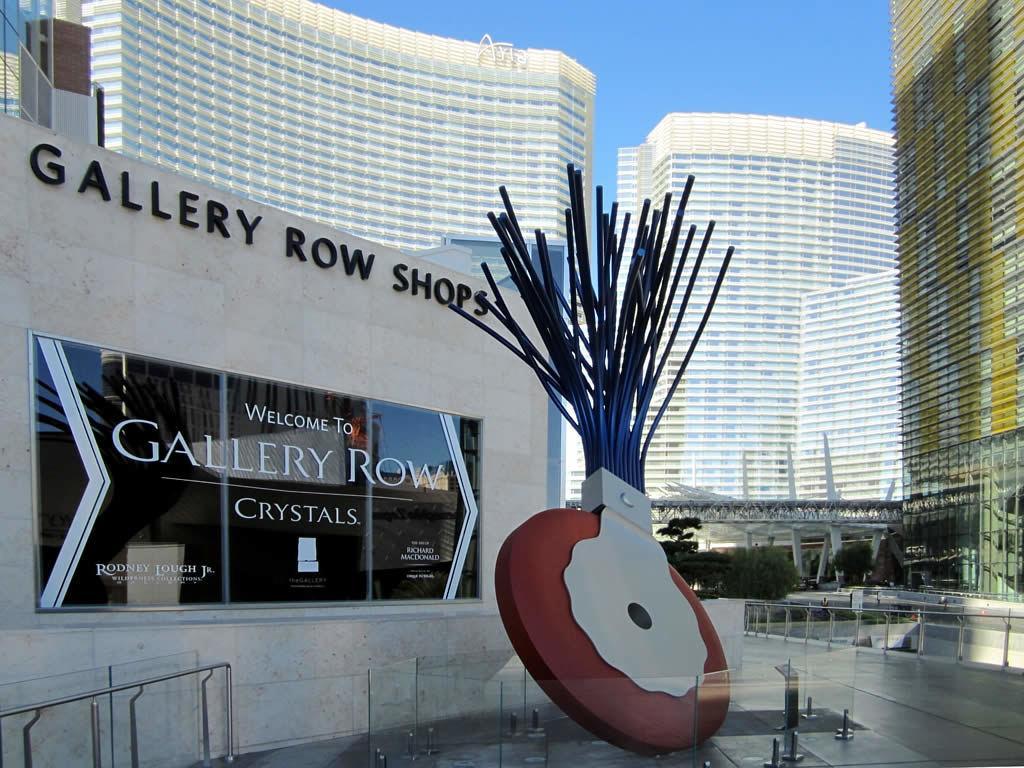Could you give a brief overview of what you see in this image? In this picture I can see there are buildings here and the buildings have glass windows and the sky is clear. 